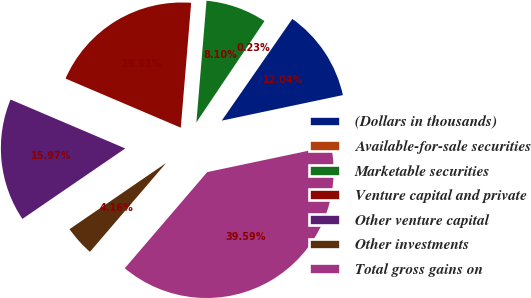Convert chart to OTSL. <chart><loc_0><loc_0><loc_500><loc_500><pie_chart><fcel>(Dollars in thousands)<fcel>Available-for-sale securities<fcel>Marketable securities<fcel>Venture capital and private<fcel>Other venture capital<fcel>Other investments<fcel>Total gross gains on<nl><fcel>12.04%<fcel>0.23%<fcel>8.1%<fcel>19.91%<fcel>15.97%<fcel>4.16%<fcel>39.59%<nl></chart> 